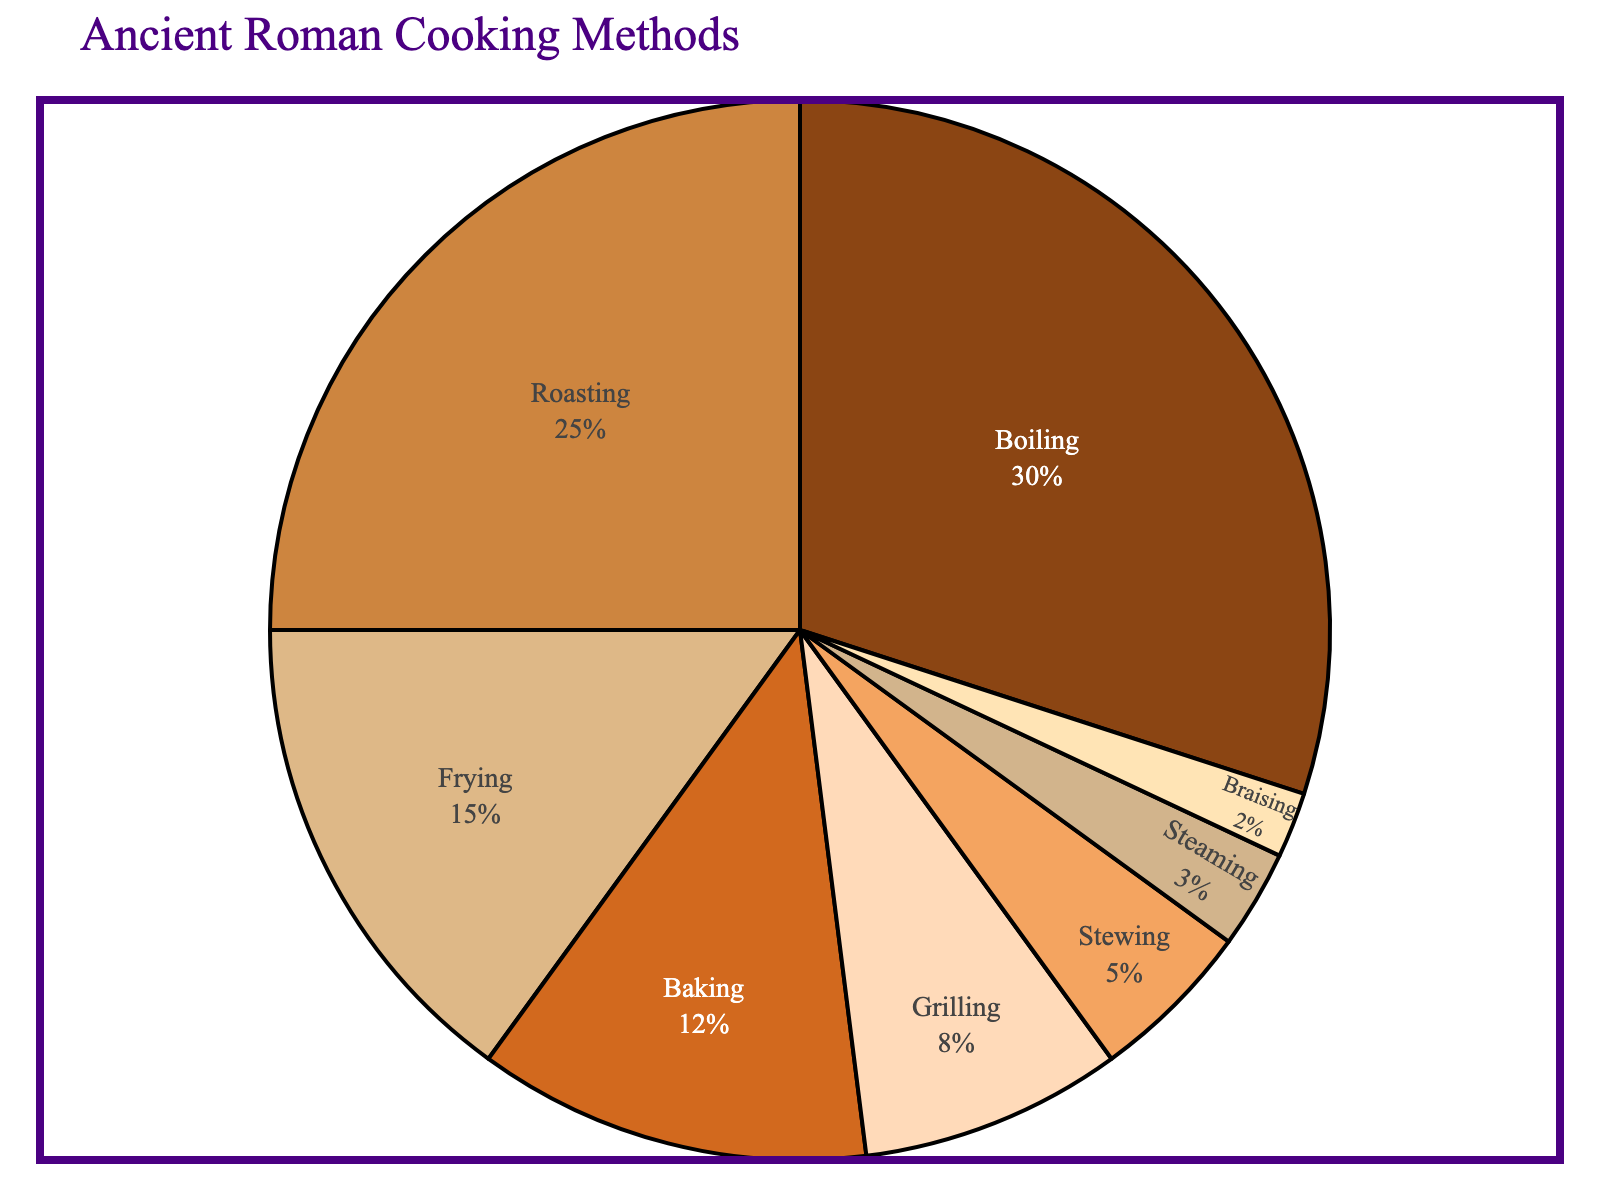What is the most popular cooking method in ancient Roman recipes? By looking at the pie chart, we see that the largest slice represents 'Boiling', with a 30% proportion.
Answer: Boiling Which cooking method accounts for twice the percentage of grilling in the recipes? Grilling accounts for 8%, and we look for a slice that represents 16%, which does not exist. Thus, none of the methods account for exactly twice the percentage of grilling.
Answer: None What is the combined percentage of boiling and roasting methods? Boiling has 30% and roasting has 25%. Adding these together, 30% + 25% = 55%.
Answer: 55% How does the percentage of baking compare to frying? Baking represents 12% and frying 15%. Since 12% is less than 15%, baking is less common than frying in the recipes.
Answer: Baking is less common What is the percentage difference between the most and least popular cooking methods? The most popular method is boiling (30%) and the least popular is braising (2%). The difference is 30% - 2% = 28%.
Answer: 28% Which color represents the slice for stewing, and what is its proportion? Stewing is represented by a lighter brown slice and has a proportion of 5%.
Answer: Light brown, 5% If we combine the percentages of grilling, steaming, and braising, what do we get? Grilling is 8%, steaming is 3%, and braising is 2%. Adding these together, 8% + 3% + 2% = 13%.
Answer: 13% Which is greater, the combined percentage of roasting and frying, or the percentage of boiling? Roasting is 25% and frying is 15%. Their combined percentage is 25% + 15% = 40%. Since boiling is 30%, 40% is greater than 30%.
Answer: Combined percentage of roasting and frying Rank the cooking methods from highest to lowest percentage. By observing the chart, we note the following order: Boiling (30%), Roasting (25%), Frying (15%), Baking (12%), Grilling (8%), Stewing (5%), Steaming (3%), Braising (2%).
Answer: Boiling, Roasting, Frying, Baking, Grilling, Stewing, Steaming, Braising Is the percentage of roasting methods closer to boiling or frying? Roasting is 25%, boiling is 30%, and frying is 15%. The difference with boiling is 30% - 25% = 5%, and with frying is 25% - 15% = 10%. Hence, it is closer to boiling.
Answer: Boiling 